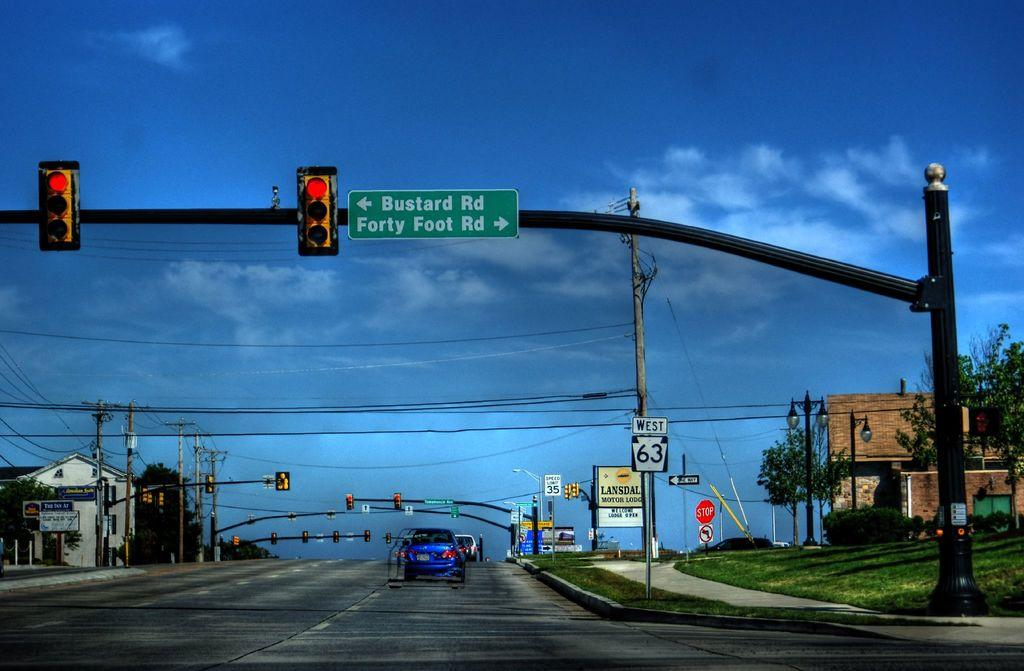<image>
Provide a brief description of the given image. A street sign for Bustard Road hangs from a traffic light pole. 